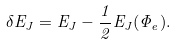Convert formula to latex. <formula><loc_0><loc_0><loc_500><loc_500>\delta E _ { J } = E _ { J } - \frac { 1 } { 2 } E _ { J } ( \Phi _ { e } ) .</formula> 